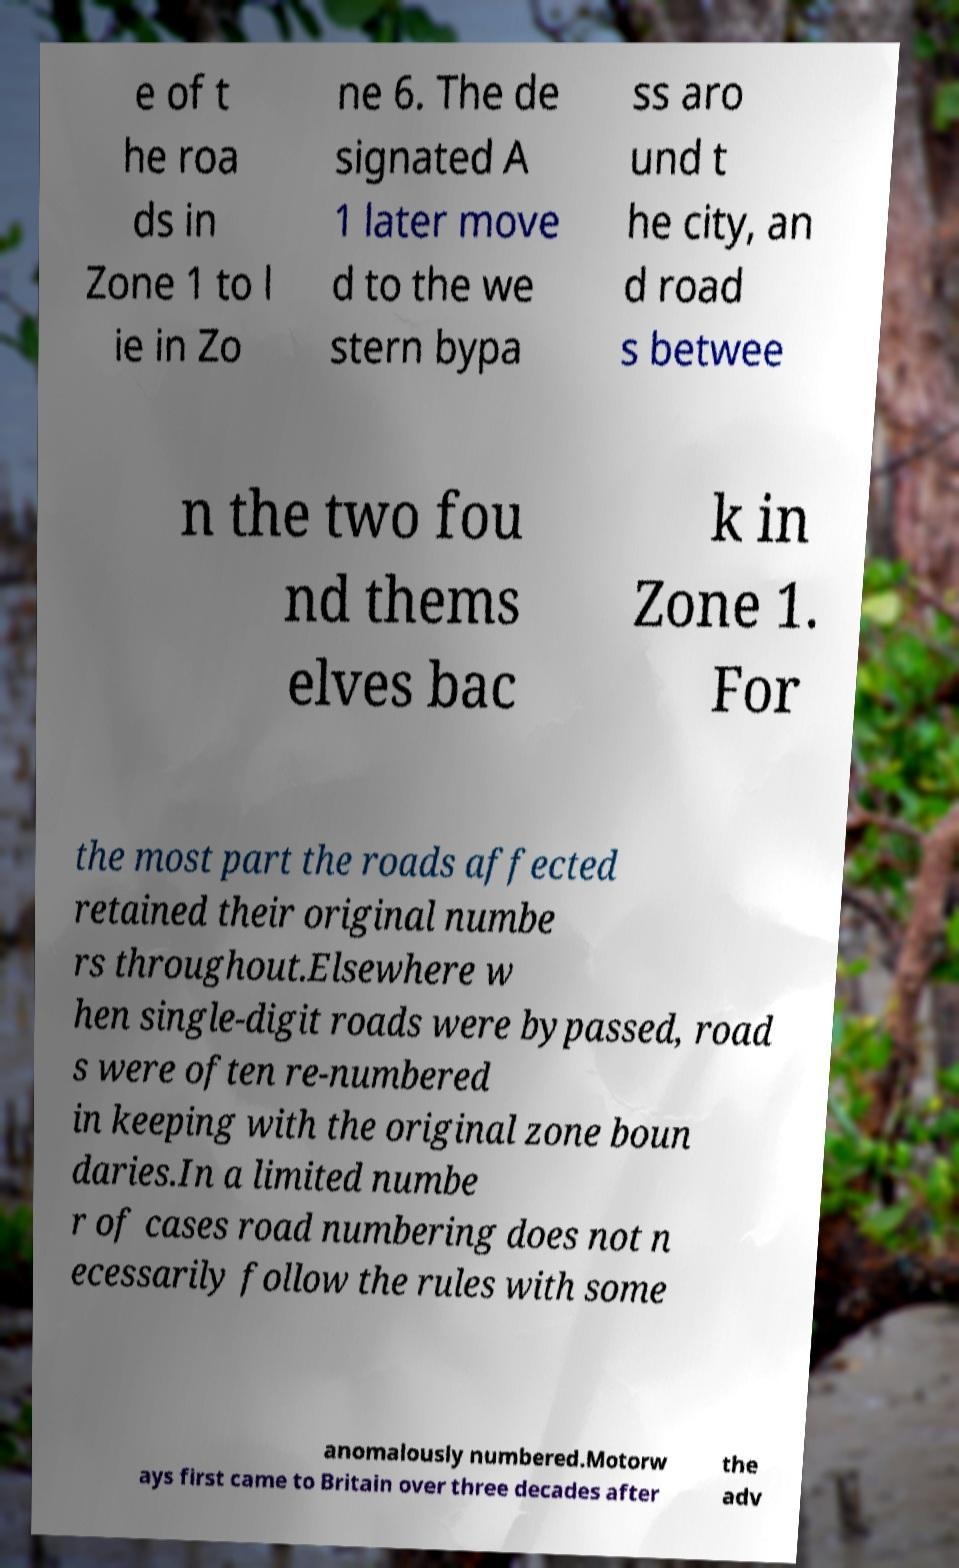Please identify and transcribe the text found in this image. e of t he roa ds in Zone 1 to l ie in Zo ne 6. The de signated A 1 later move d to the we stern bypa ss aro und t he city, an d road s betwee n the two fou nd thems elves bac k in Zone 1. For the most part the roads affected retained their original numbe rs throughout.Elsewhere w hen single-digit roads were bypassed, road s were often re-numbered in keeping with the original zone boun daries.In a limited numbe r of cases road numbering does not n ecessarily follow the rules with some anomalously numbered.Motorw ays first came to Britain over three decades after the adv 